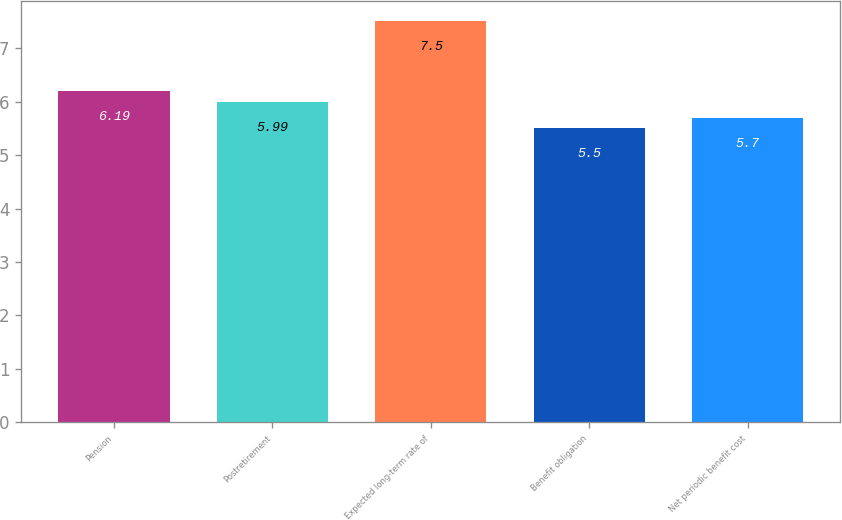Convert chart. <chart><loc_0><loc_0><loc_500><loc_500><bar_chart><fcel>Pension<fcel>Postretirement<fcel>Expected long-term rate of<fcel>Benefit obligation<fcel>Net periodic benefit cost<nl><fcel>6.19<fcel>5.99<fcel>7.5<fcel>5.5<fcel>5.7<nl></chart> 